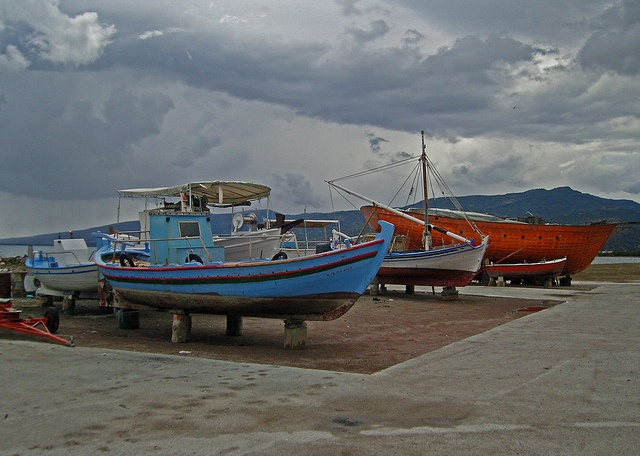Describe the objects in this image and their specific colors. I can see boat in darkgray, black, blue, and gray tones, boat in darkgray, gray, black, and maroon tones, boat in darkgray, maroon, black, and gray tones, boat in darkgray, gray, and black tones, and boat in darkgray, black, maroon, and gray tones in this image. 